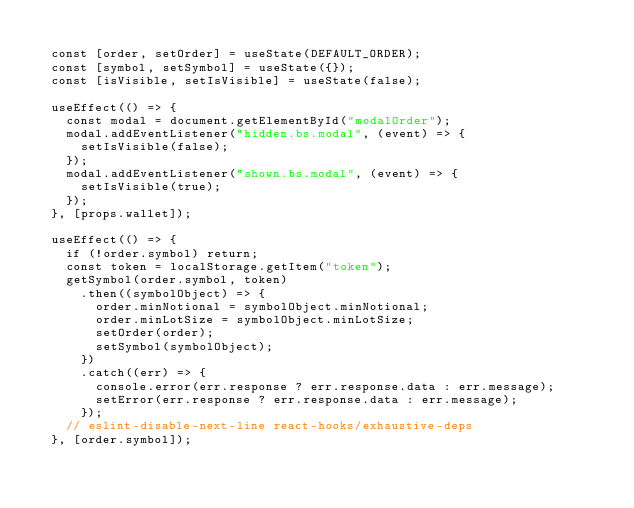<code> <loc_0><loc_0><loc_500><loc_500><_JavaScript_>
  const [order, setOrder] = useState(DEFAULT_ORDER);
  const [symbol, setSymbol] = useState({});
  const [isVisible, setIsVisible] = useState(false);

  useEffect(() => {
    const modal = document.getElementById("modalOrder");
    modal.addEventListener("hidden.bs.modal", (event) => {
      setIsVisible(false);
    });
    modal.addEventListener("shown.bs.modal", (event) => {
      setIsVisible(true);
    });
  }, [props.wallet]);

  useEffect(() => {
    if (!order.symbol) return;
    const token = localStorage.getItem("token");
    getSymbol(order.symbol, token)
      .then((symbolObject) => {
        order.minNotional = symbolObject.minNotional;
        order.minLotSize = symbolObject.minLotSize;
        setOrder(order);
        setSymbol(symbolObject);
      })
      .catch((err) => {
        console.error(err.response ? err.response.data : err.message);
        setError(err.response ? err.response.data : err.message);
      });
    // eslint-disable-next-line react-hooks/exhaustive-deps
  }, [order.symbol]);
</code> 